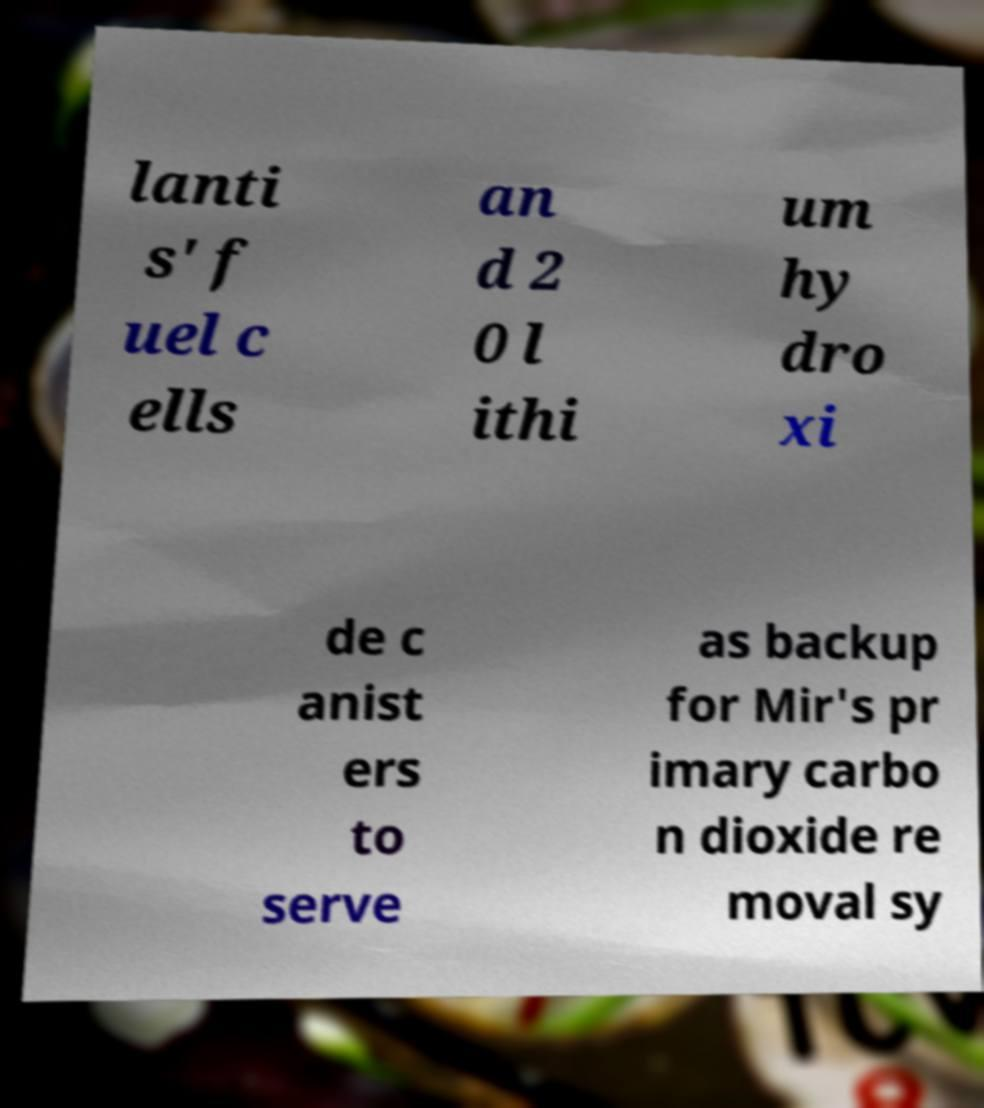Can you accurately transcribe the text from the provided image for me? lanti s' f uel c ells an d 2 0 l ithi um hy dro xi de c anist ers to serve as backup for Mir's pr imary carbo n dioxide re moval sy 